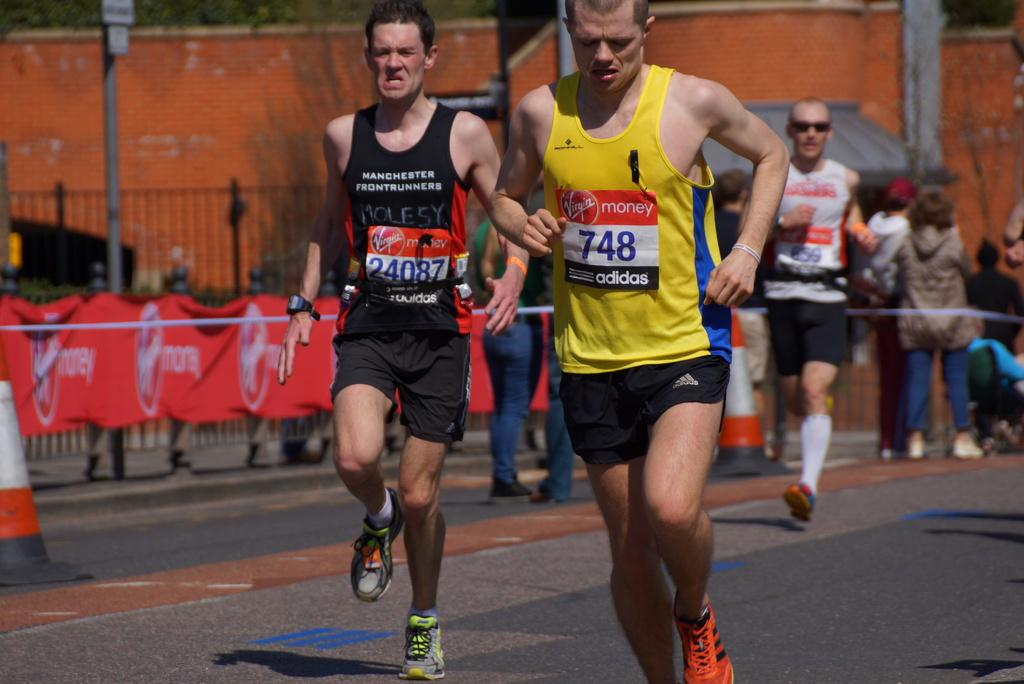What are the three people in the image doing? The three people in the image are running on the road. What objects are placed behind the people? There are traffic cones, a banner, iron grilles, poles, people, a wall, and some unspecified objects behind the people. Can you describe the banner in the image? The banner is located behind the people, but its content or design cannot be determined from the provided facts. What type of surface are the people running on? The people are running on a road. What type of horse can be seen running alongside the people in the image? There is no horse present in the image; the people are running on the road without any animals. What type of creature is depicted on the banner behind the people? The content or design of the banner cannot be determined from the provided facts, so it is impossible to answer this question. 